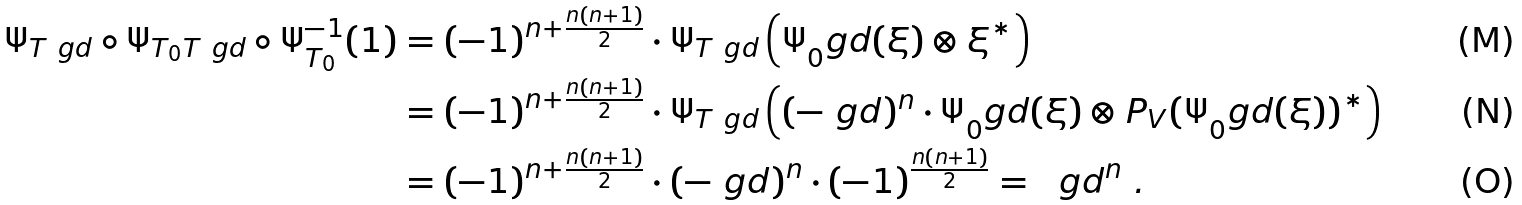<formula> <loc_0><loc_0><loc_500><loc_500>\Psi _ { T _ { \ } g d } \circ \Psi _ { T _ { 0 } T _ { \ } g d } \circ \Psi _ { T _ { 0 } } ^ { - 1 } ( 1 ) & = ( - 1 ) ^ { n + \frac { n ( n + 1 ) } 2 } \cdot \Psi _ { T _ { \ } g d } \left ( \Psi _ { 0 } ^ { \ } g d ( \xi ) \otimes \xi ^ { * } \right ) \\ & = ( - 1 ) ^ { n + \frac { n ( n + 1 ) } 2 } \cdot \Psi _ { T _ { \ } g d } \left ( ( - \ g d ) ^ { n } \cdot \Psi _ { 0 } ^ { \ } g d ( \xi ) \otimes P _ { V } ( \Psi _ { 0 } ^ { \ } g d ( \xi ) ) ^ { * } \right ) \\ & = ( - 1 ) ^ { n + \frac { n ( n + 1 ) } 2 } \cdot ( - \ g d ) ^ { n } \cdot ( - 1 ) ^ { \frac { n ( n + 1 ) } 2 } = \ \ g d ^ { n } \ .</formula> 